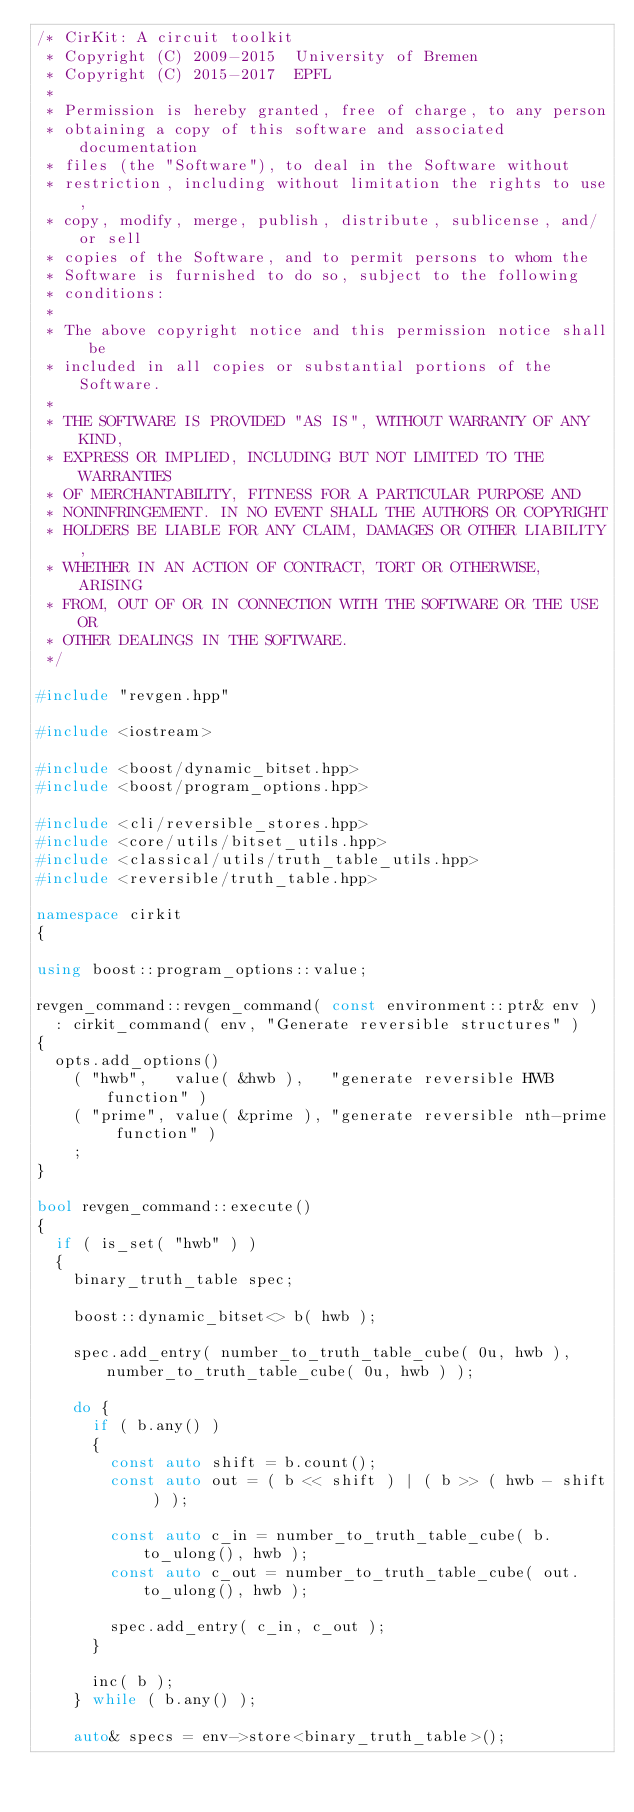Convert code to text. <code><loc_0><loc_0><loc_500><loc_500><_C++_>/* CirKit: A circuit toolkit
 * Copyright (C) 2009-2015  University of Bremen
 * Copyright (C) 2015-2017  EPFL
 *
 * Permission is hereby granted, free of charge, to any person
 * obtaining a copy of this software and associated documentation
 * files (the "Software"), to deal in the Software without
 * restriction, including without limitation the rights to use,
 * copy, modify, merge, publish, distribute, sublicense, and/or sell
 * copies of the Software, and to permit persons to whom the
 * Software is furnished to do so, subject to the following
 * conditions:
 *
 * The above copyright notice and this permission notice shall be
 * included in all copies or substantial portions of the Software.
 *
 * THE SOFTWARE IS PROVIDED "AS IS", WITHOUT WARRANTY OF ANY KIND,
 * EXPRESS OR IMPLIED, INCLUDING BUT NOT LIMITED TO THE WARRANTIES
 * OF MERCHANTABILITY, FITNESS FOR A PARTICULAR PURPOSE AND
 * NONINFRINGEMENT. IN NO EVENT SHALL THE AUTHORS OR COPYRIGHT
 * HOLDERS BE LIABLE FOR ANY CLAIM, DAMAGES OR OTHER LIABILITY,
 * WHETHER IN AN ACTION OF CONTRACT, TORT OR OTHERWISE, ARISING
 * FROM, OUT OF OR IN CONNECTION WITH THE SOFTWARE OR THE USE OR
 * OTHER DEALINGS IN THE SOFTWARE.
 */

#include "revgen.hpp"

#include <iostream>

#include <boost/dynamic_bitset.hpp>
#include <boost/program_options.hpp>

#include <cli/reversible_stores.hpp>
#include <core/utils/bitset_utils.hpp>
#include <classical/utils/truth_table_utils.hpp>
#include <reversible/truth_table.hpp>

namespace cirkit
{

using boost::program_options::value;

revgen_command::revgen_command( const environment::ptr& env )
  : cirkit_command( env, "Generate reversible structures" )
{
  opts.add_options()
    ( "hwb",   value( &hwb ),   "generate reversible HWB function" )
    ( "prime", value( &prime ), "generate reversible nth-prime function" )
    ;
}

bool revgen_command::execute()
{
  if ( is_set( "hwb" ) )
  {
    binary_truth_table spec;

    boost::dynamic_bitset<> b( hwb );

    spec.add_entry( number_to_truth_table_cube( 0u, hwb ), number_to_truth_table_cube( 0u, hwb ) );

    do {
      if ( b.any() )
      {
        const auto shift = b.count();
        const auto out = ( b << shift ) | ( b >> ( hwb - shift ) );

        const auto c_in = number_to_truth_table_cube( b.to_ulong(), hwb );
        const auto c_out = number_to_truth_table_cube( out.to_ulong(), hwb );

        spec.add_entry( c_in, c_out );
      }

      inc( b );
    } while ( b.any() );

    auto& specs = env->store<binary_truth_table>();
</code> 